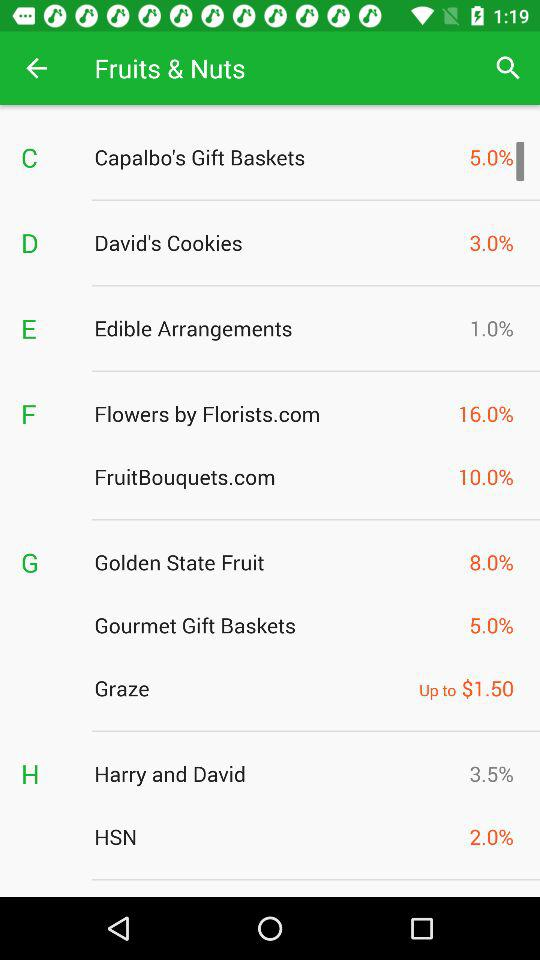Which businesses are listed in B?
When the provided information is insufficient, respond with <no answer>. <no answer> 